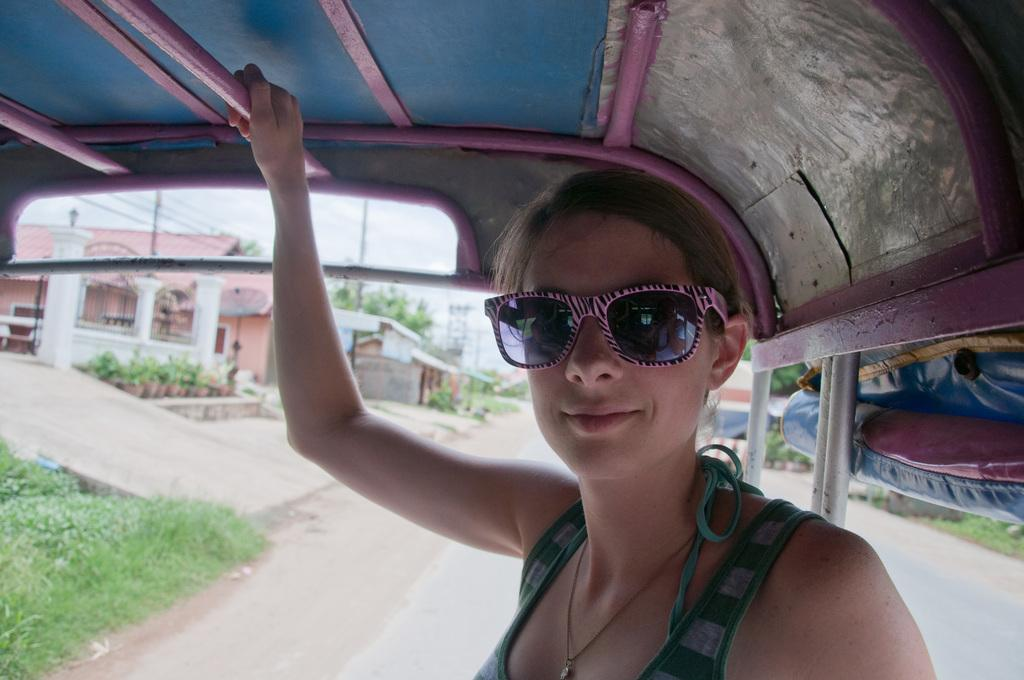Who is in the vehicle in the image? There is a lady in the vehicle in the image. What can be observed about the lady's appearance? The lady is wearing glasses. What can be seen in the background of the image? There are trees and buildings in the background of the image. What other objects are visible in the image? There are poles visible in the image. What is at the bottom of the image? There is a road at the bottom of the image. What type of wire is being used to make popcorn in the image? There is no wire or popcorn present in the image. What riddle is the lady trying to solve in the image? There is no riddle or indication of a riddle-solving activity in the image. 